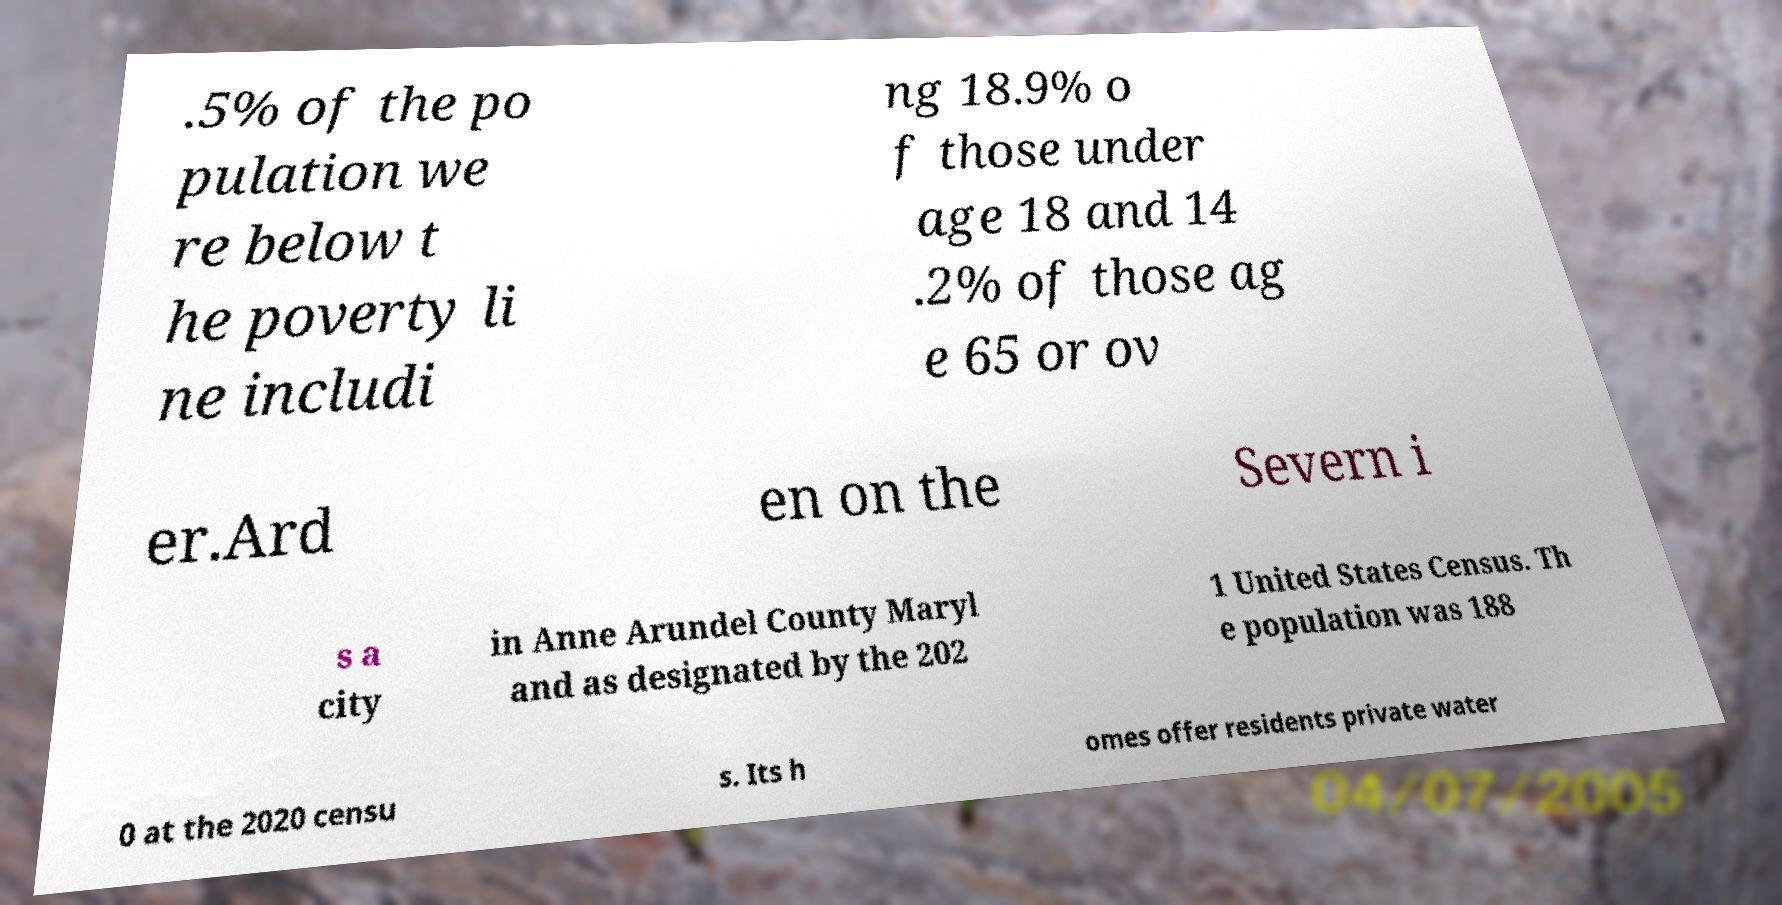For documentation purposes, I need the text within this image transcribed. Could you provide that? .5% of the po pulation we re below t he poverty li ne includi ng 18.9% o f those under age 18 and 14 .2% of those ag e 65 or ov er.Ard en on the Severn i s a city in Anne Arundel County Maryl and as designated by the 202 1 United States Census. Th e population was 188 0 at the 2020 censu s. Its h omes offer residents private water 